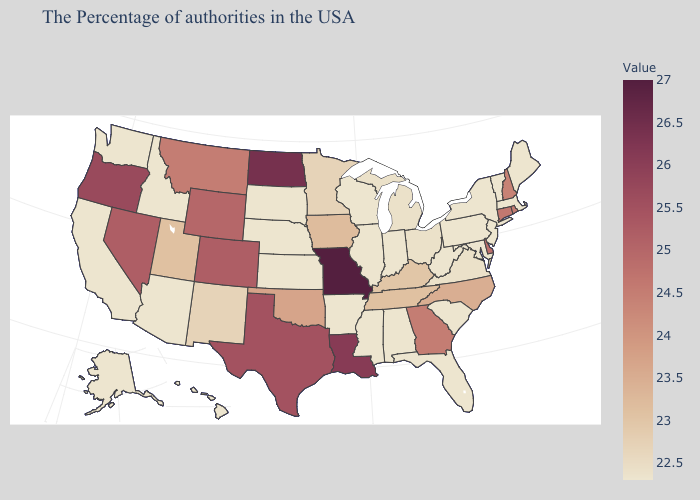Does New Mexico have the lowest value in the USA?
Give a very brief answer. No. Among the states that border Texas , does Oklahoma have the highest value?
Short answer required. No. 